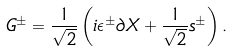<formula> <loc_0><loc_0><loc_500><loc_500>G ^ { \pm } = { \frac { 1 } { \sqrt { 2 } } } \left ( i \epsilon ^ { \pm } \partial X + { \frac { 1 } { \sqrt { 2 } } } s ^ { \pm } \right ) .</formula> 